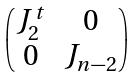<formula> <loc_0><loc_0><loc_500><loc_500>\begin{pmatrix} J ^ { t } _ { 2 } & 0 \\ 0 & J _ { n - 2 } \\ \end{pmatrix}</formula> 